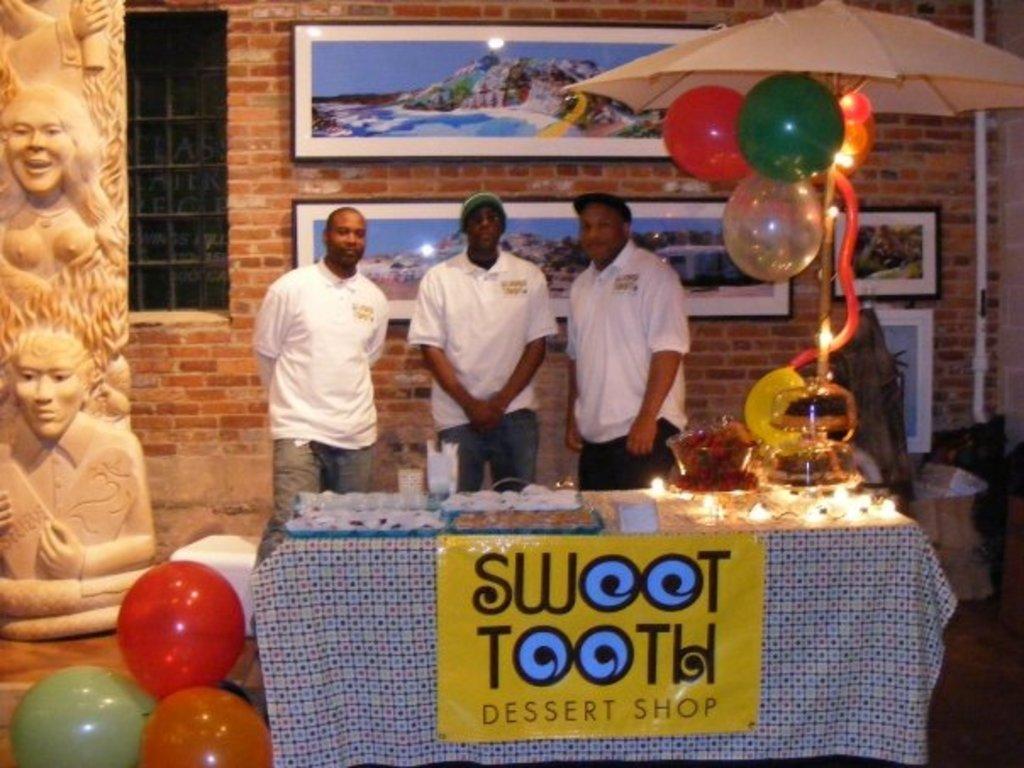How would you summarize this image in a sentence or two? In this image we can see three persons standing, there is a table cover with a cloth and there are few objects on the table, there is an umbrella and few balloons attached to it, there are few balloons beside the table, there is a pillar with design, there is a wall with picture frames and a window and there are few objects on the floor. 